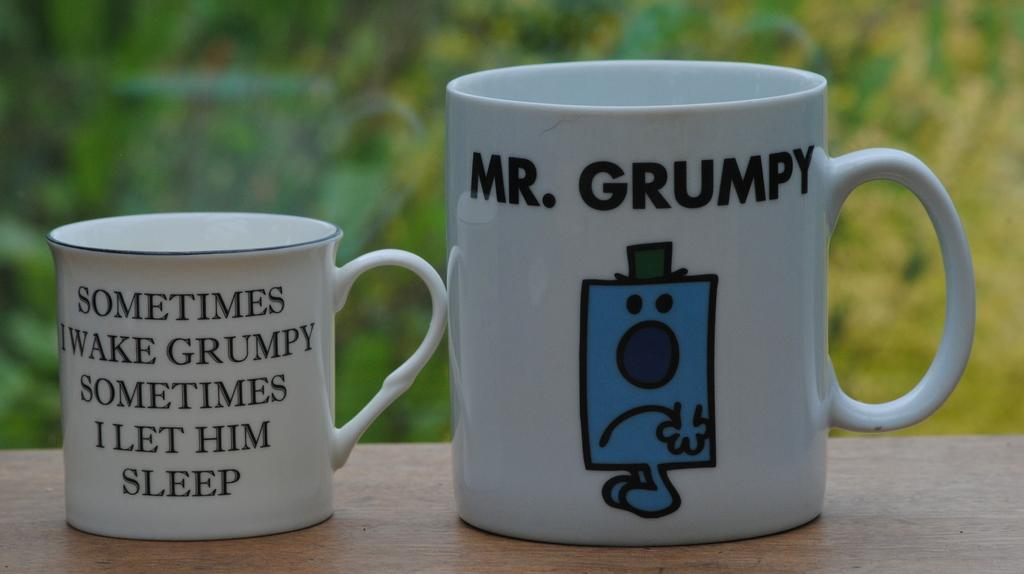<image>
Describe the image concisely. Two different sized coffee mugs with mr grumpy on the right and joke text on the left. 